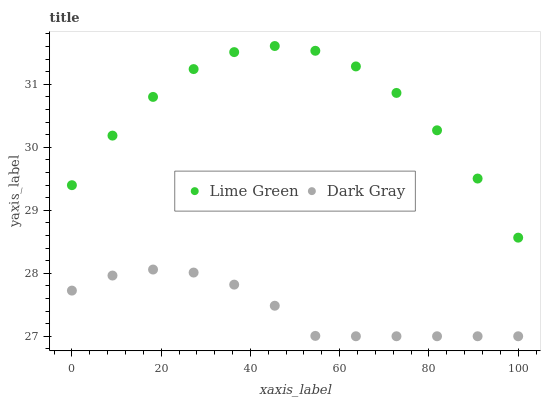Does Dark Gray have the minimum area under the curve?
Answer yes or no. Yes. Does Lime Green have the maximum area under the curve?
Answer yes or no. Yes. Does Lime Green have the minimum area under the curve?
Answer yes or no. No. Is Dark Gray the smoothest?
Answer yes or no. Yes. Is Lime Green the roughest?
Answer yes or no. Yes. Is Lime Green the smoothest?
Answer yes or no. No. Does Dark Gray have the lowest value?
Answer yes or no. Yes. Does Lime Green have the lowest value?
Answer yes or no. No. Does Lime Green have the highest value?
Answer yes or no. Yes. Is Dark Gray less than Lime Green?
Answer yes or no. Yes. Is Lime Green greater than Dark Gray?
Answer yes or no. Yes. Does Dark Gray intersect Lime Green?
Answer yes or no. No. 